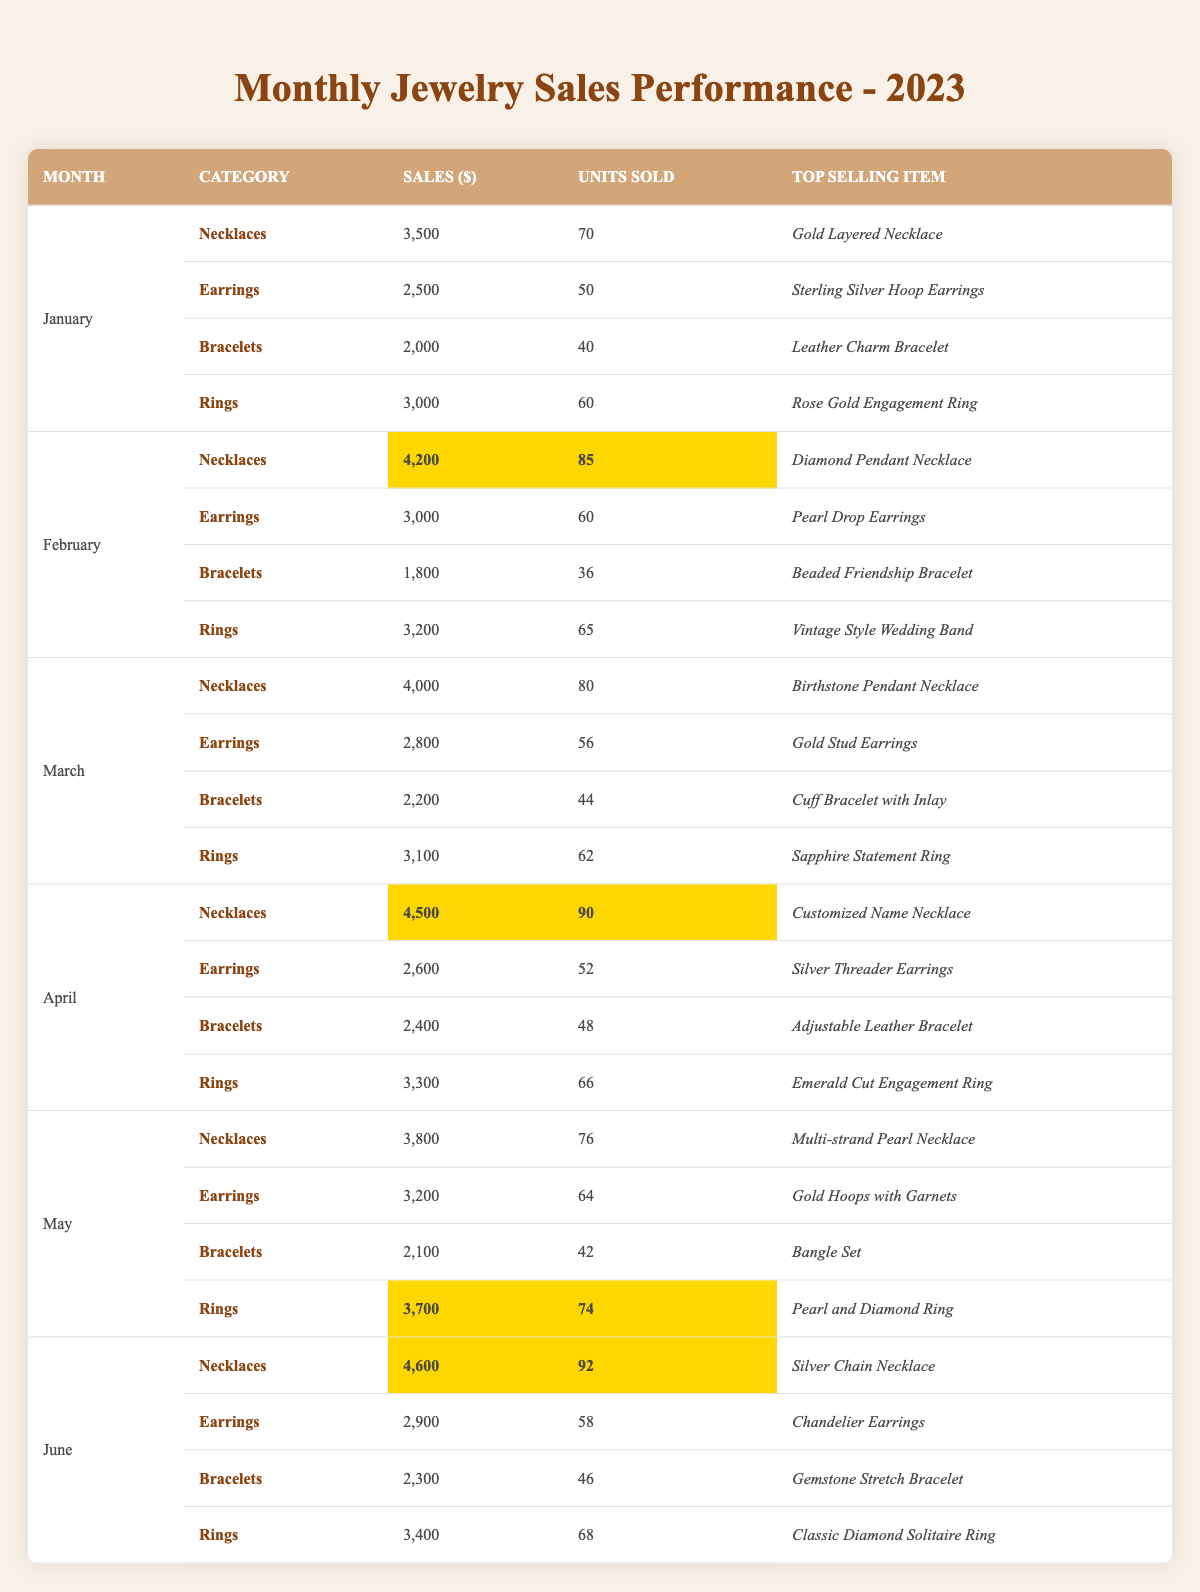What were the total sales for necklaces in June? The sales for necklaces in June are highlighted in the table and are shown as 4,600.
Answer: 4,600 How many units of earrings were sold in February? The units sold for earrings in February are explicitly listed in the table, which shows 60 units.
Answer: 60 Which category had the highest sales in April? In April, the sales for the categories are as follows: Necklaces - 4,500, Earrings - 2,600, Bracelets - 2,400, and Rings - 3,300. Necklaces had the highest sales at 4,500.
Answer: Necklaces What is the average sales amount for rings over the first six months? The sales for rings from January to June are: 3,000, 3,200, 3,100, 3,300, 3,700, and 3,400. The total sum is 3,000 + 3,200 + 3,100 + 3,300 + 3,700 + 3,400 = 19,700. There are 6 months, so the average is 19,700 / 6 = 3,283.33.
Answer: 3,283.33 Did the sales for bracelets increase from January to February? January sales for bracelets are 2,000, and February sales are 1,800, showing a decrease. Therefore, the statement is false.
Answer: No What is the total number of units sold for all categories in March? The units sold in March are: Necklaces - 80, Earrings - 56, Bracelets - 44, and Rings - 62. Adding these gives 80 + 56 + 44 + 62 = 242 units sold in March.
Answer: 242 Which item is the top-selling bracelet in April? The table shows that the top-selling item in the bracelet category for April is the "Adjustable Leather Bracelet."
Answer: Adjustable Leather Bracelet Compare the units sold of necklaces in May to those in April. In May, 76 units of necklaces were sold, while in April, 90 units were sold. Therefore, May had 14 fewer units sold than April (90 - 76 = 14).
Answer: 14 fewer What was the percentage increase in sales for necklaces from January to February? The sales for necklaces in January were 3,500, and in February were 4,200. The increase is calculated as (4,200 - 3,500) = 700. The percentage increase is (700/3,500) * 100 = 20%.
Answer: 20% What was the total sales amount in May across all categories compared to April? In May, the total sales were: Necklaces - 3,800, Earrings - 3,200, Bracelets - 2,100, and Rings - 3,700, totaling 12,800. In April, the sales were Necklaces - 4,500, Earrings - 2,600, Bracelets - 2,400, and Rings - 3,300, totaling 12,800. Both months have the same total sales amount.
Answer: Same total sales amount: 12,800 